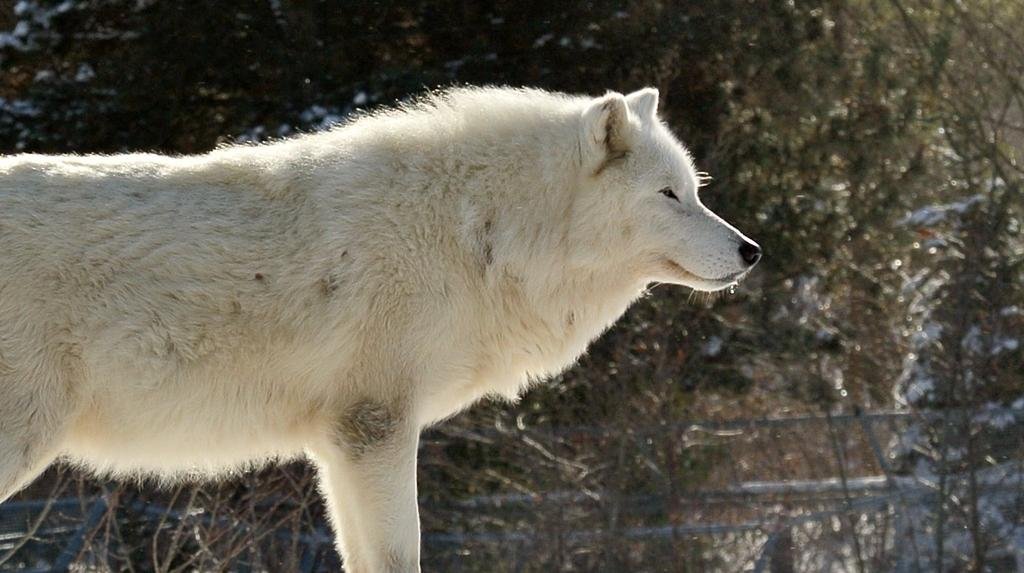What animal is the main subject of the picture? There is a white wolf in the picture. What can be seen in the background of the picture? There are trees in the background of the picture. What type of body is visible in the picture? There is no body present in the picture; it features a white wolf and trees in the background. What school is the white wolf attending in the picture? There is no school or indication of education in the picture; it features a white wolf and trees in the background. 